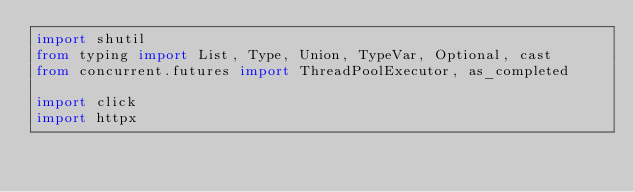Convert code to text. <code><loc_0><loc_0><loc_500><loc_500><_Python_>import shutil
from typing import List, Type, Union, TypeVar, Optional, cast
from concurrent.futures import ThreadPoolExecutor, as_completed

import click
import httpx</code> 